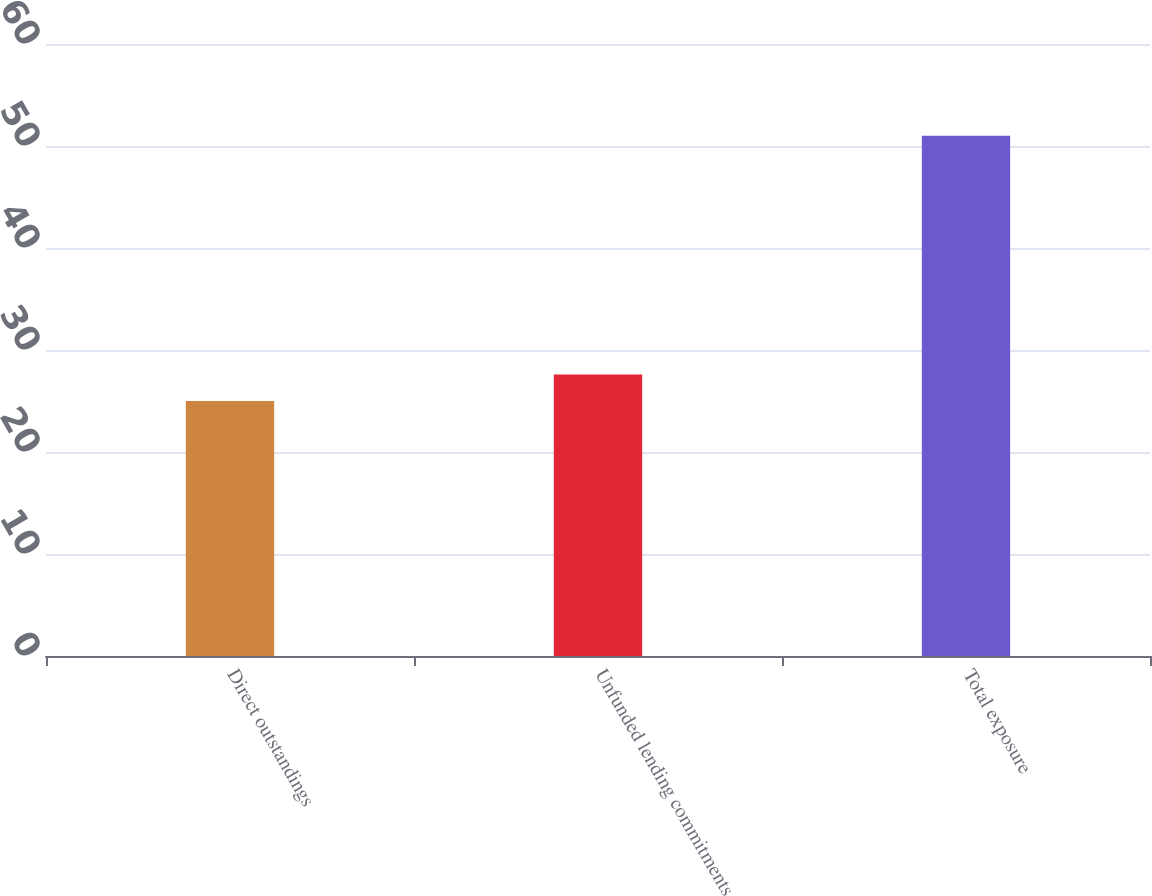Convert chart to OTSL. <chart><loc_0><loc_0><loc_500><loc_500><bar_chart><fcel>Direct outstandings<fcel>Unfunded lending commitments<fcel>Total exposure<nl><fcel>25<fcel>27.6<fcel>51<nl></chart> 